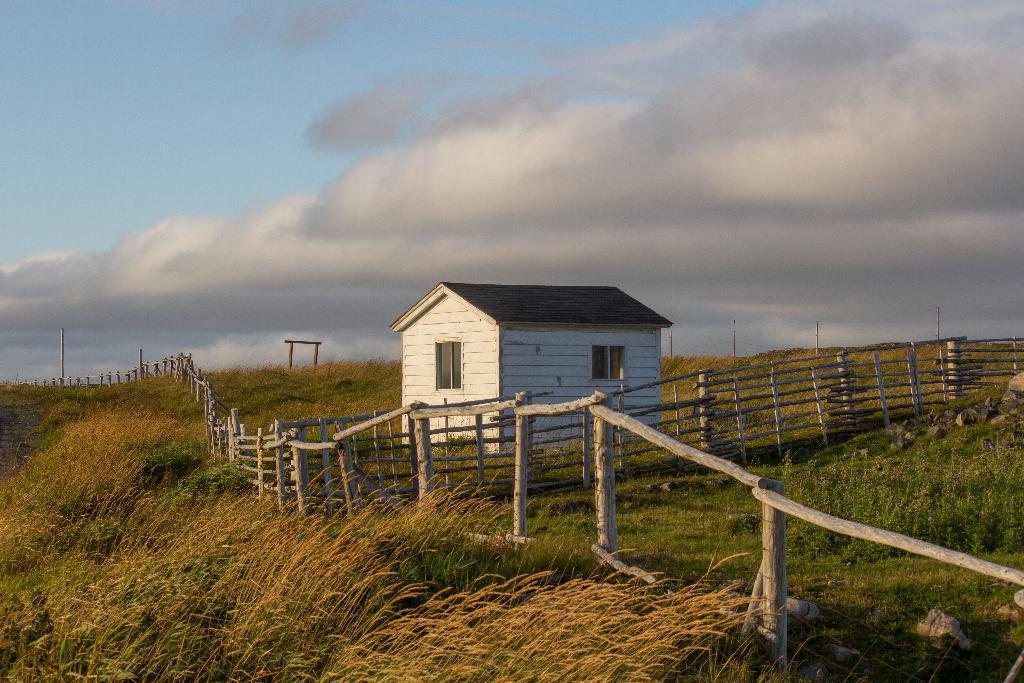How would you summarize this image in a sentence or two? In this image, we can see a house. We can also see the ground covered with grass and plants. There are some poles. We can see the sky with clouds. We can see the fence. 